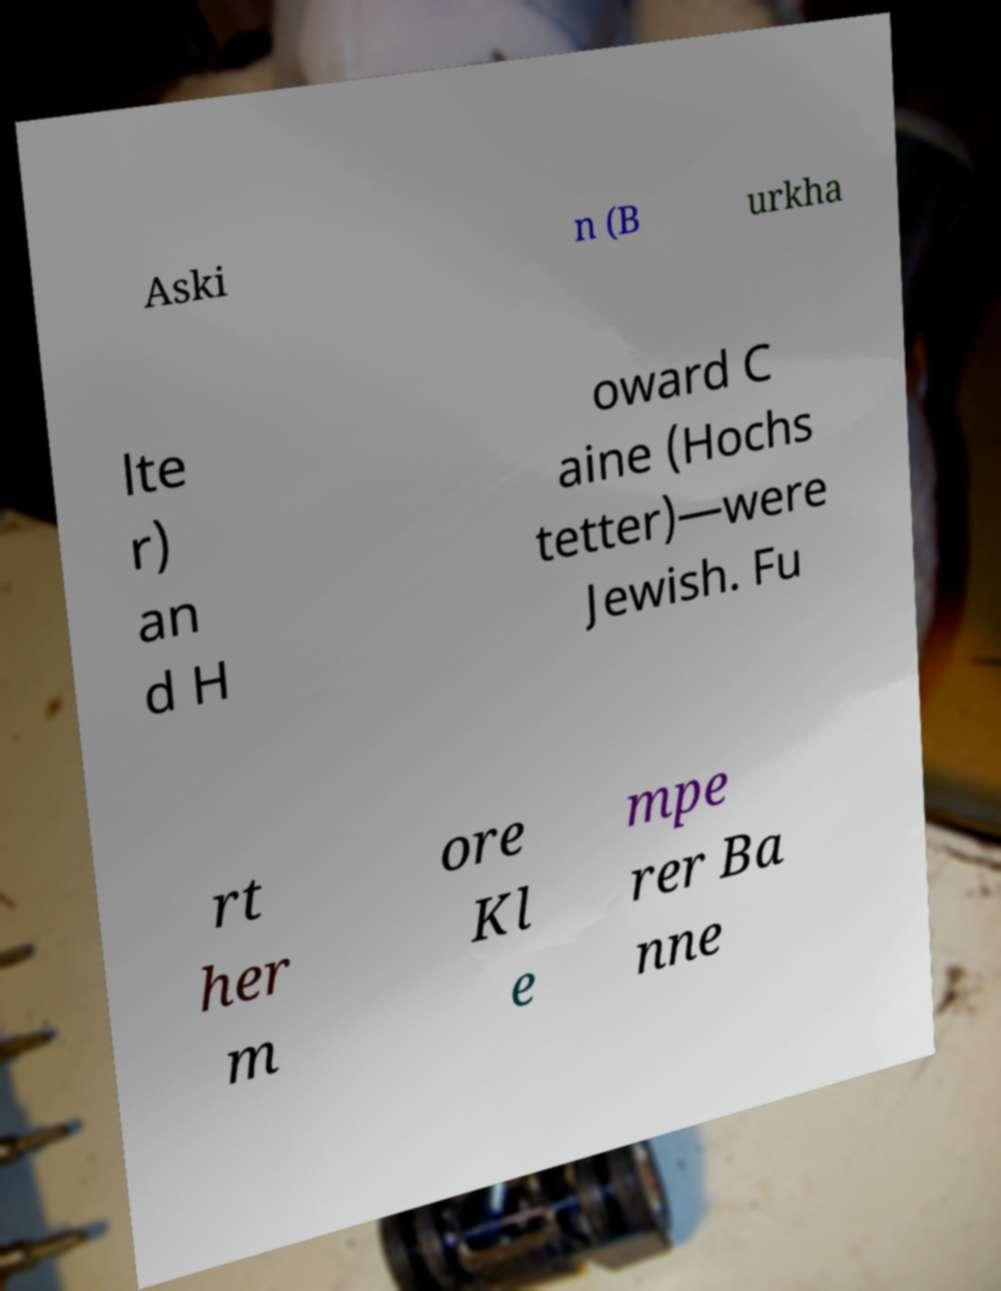There's text embedded in this image that I need extracted. Can you transcribe it verbatim? Aski n (B urkha lte r) an d H oward C aine (Hochs tetter)—were Jewish. Fu rt her m ore Kl e mpe rer Ba nne 